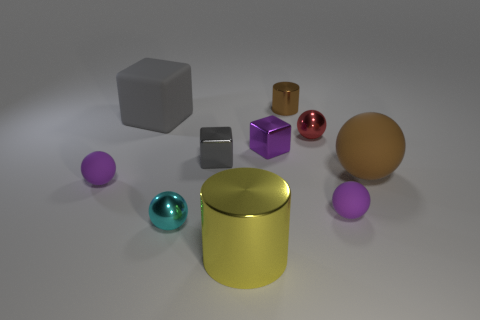Subtract all red shiny balls. How many balls are left? 4 Subtract 2 spheres. How many spheres are left? 3 Subtract all gray blocks. Subtract all yellow balls. How many blocks are left? 1 Subtract all cyan balls. How many gray blocks are left? 2 Subtract all large shiny objects. Subtract all tiny red shiny spheres. How many objects are left? 8 Add 1 tiny cyan things. How many tiny cyan things are left? 2 Add 1 small cyan metal cubes. How many small cyan metal cubes exist? 1 Subtract all cyan balls. How many balls are left? 4 Subtract 0 gray spheres. How many objects are left? 10 Subtract all cylinders. How many objects are left? 8 